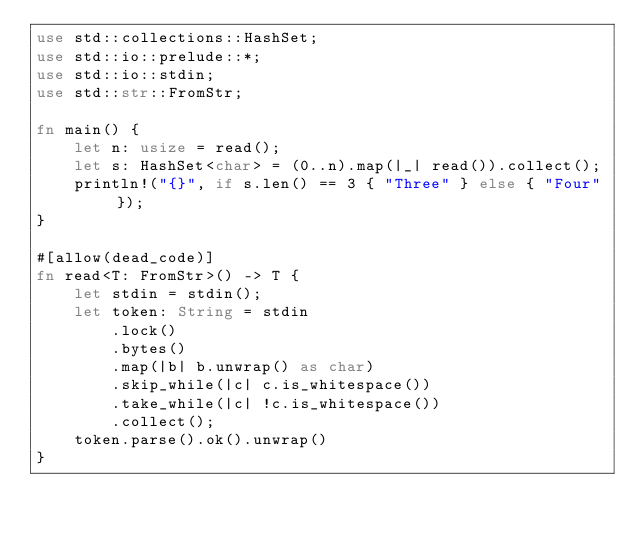<code> <loc_0><loc_0><loc_500><loc_500><_Rust_>use std::collections::HashSet;
use std::io::prelude::*;
use std::io::stdin;
use std::str::FromStr;

fn main() {
    let n: usize = read();
    let s: HashSet<char> = (0..n).map(|_| read()).collect();
    println!("{}", if s.len() == 3 { "Three" } else { "Four" });
}

#[allow(dead_code)]
fn read<T: FromStr>() -> T {
    let stdin = stdin();
    let token: String = stdin
        .lock()
        .bytes()
        .map(|b| b.unwrap() as char)
        .skip_while(|c| c.is_whitespace())
        .take_while(|c| !c.is_whitespace())
        .collect();
    token.parse().ok().unwrap()
}
</code> 